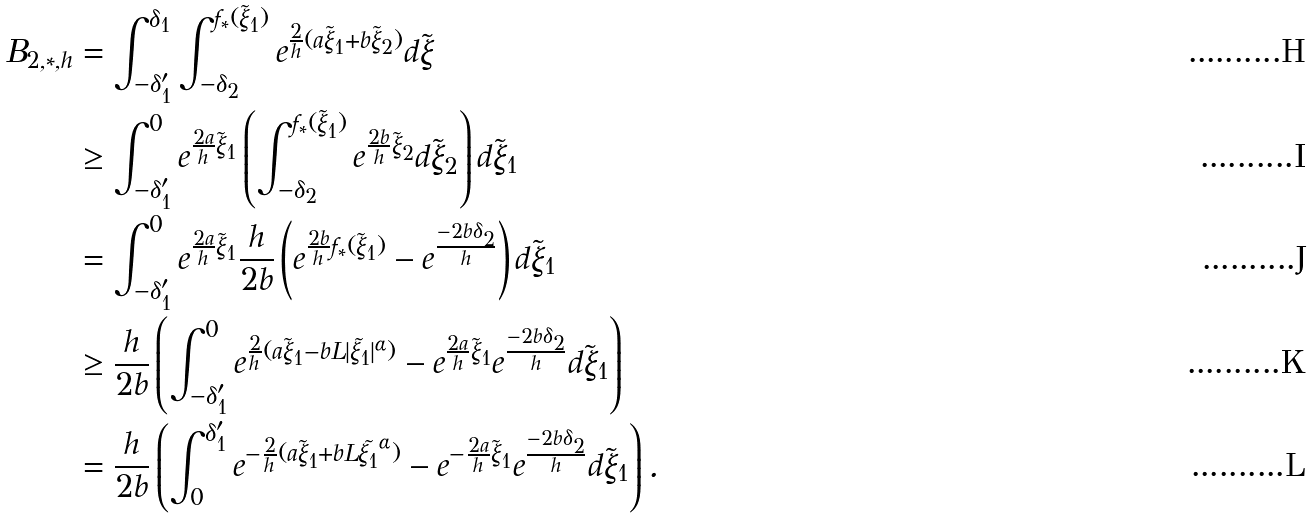Convert formula to latex. <formula><loc_0><loc_0><loc_500><loc_500>B _ { 2 , * , h } & = \int _ { - \delta _ { 1 } ^ { \prime } } ^ { \delta _ { 1 } } \int _ { - \delta _ { 2 } } ^ { f _ { * } ( \tilde { \xi } _ { 1 } ) } e ^ { \frac { 2 } { h } ( a \tilde { \xi } _ { 1 } + b \tilde { \xi } _ { 2 } ) } d \tilde { \xi } \\ & \geq \int _ { - \delta _ { 1 } ^ { \prime } } ^ { 0 } e ^ { \frac { 2 a } { h } \tilde { \xi } _ { 1 } } \left ( \int _ { - \delta _ { 2 } } ^ { f _ { * } ( \tilde { \xi } _ { 1 } ) } e ^ { \frac { 2 b } { h } \tilde { \xi } _ { 2 } } d \tilde { \xi } _ { 2 } \right ) d \tilde { \xi } _ { 1 } \\ & = \int _ { - \delta _ { 1 } ^ { \prime } } ^ { 0 } e ^ { \frac { 2 a } { h } \tilde { \xi } _ { 1 } } \frac { h } { 2 b } \left ( e ^ { \frac { 2 b } { h } f _ { * } ( \tilde { \xi } _ { 1 } ) } - e ^ { \frac { - 2 b \delta _ { 2 } } { h } } \right ) d \tilde { \xi } _ { 1 } \\ & \geq \frac { h } { 2 b } \left ( \int _ { - \delta _ { 1 } ^ { \prime } } ^ { 0 } e ^ { \frac { 2 } { h } ( a \tilde { \xi } _ { 1 } - b L | \tilde { \xi _ { 1 } } | ^ { \alpha } ) } - e ^ { \frac { 2 a } { h } \tilde { \xi } _ { 1 } } e ^ { \frac { - 2 b \delta _ { 2 } } { h } } d \tilde { \xi } _ { 1 } \right ) \\ & = \frac { h } { 2 b } \left ( \int _ { 0 } ^ { \delta _ { 1 } ^ { \prime } } e ^ { - \frac { 2 } { h } ( a \tilde { \xi } _ { 1 } + b L \tilde { \xi _ { 1 } } ^ { \alpha } ) } - e ^ { - \frac { 2 a } { h } \tilde { \xi } _ { 1 } } e ^ { \frac { - 2 b \delta _ { 2 } } { h } } d \tilde { \xi } _ { 1 } \right ) .</formula> 